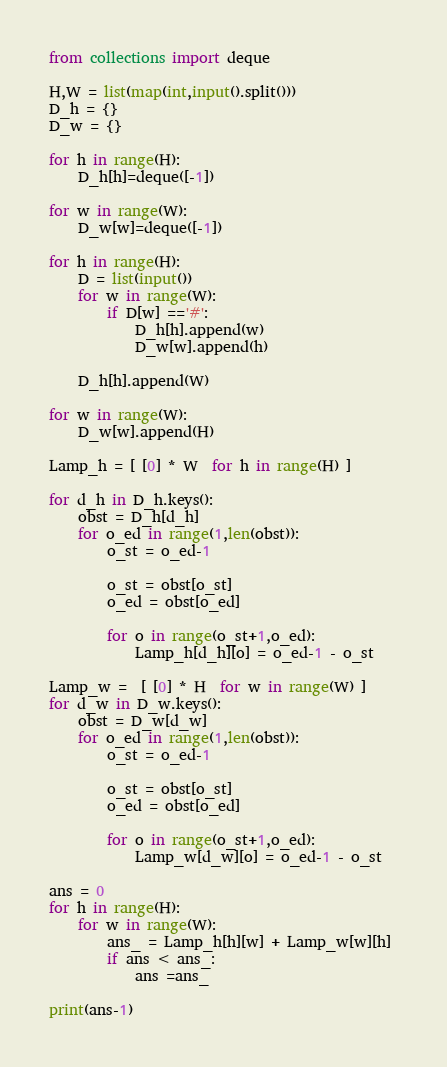Convert code to text. <code><loc_0><loc_0><loc_500><loc_500><_Python_>from collections import deque

H,W = list(map(int,input().split()))
D_h = {}
D_w = {}

for h in range(H):
    D_h[h]=deque([-1])
    
for w in range(W):
    D_w[w]=deque([-1])
    
for h in range(H):
    D = list(input())
    for w in range(W):
        if D[w] =='#':
            D_h[h].append(w)
            D_w[w].append(h)
            
    D_h[h].append(W)
    
for w in range(W):
    D_w[w].append(H)
    
Lamp_h = [ [0] * W  for h in range(H) ]

for d_h in D_h.keys():
    obst = D_h[d_h]
    for o_ed in range(1,len(obst)):
        o_st = o_ed-1
        
        o_st = obst[o_st]
        o_ed = obst[o_ed]
        
        for o in range(o_st+1,o_ed):
            Lamp_h[d_h][o] = o_ed-1 - o_st
    
Lamp_w =  [ [0] * H  for w in range(W) ]
for d_w in D_w.keys():
    obst = D_w[d_w]
    for o_ed in range(1,len(obst)):
        o_st = o_ed-1
        
        o_st = obst[o_st]
        o_ed = obst[o_ed]
        
        for o in range(o_st+1,o_ed):
            Lamp_w[d_w][o] = o_ed-1 - o_st
    
ans = 0
for h in range(H):
    for w in range(W):
        ans_ = Lamp_h[h][w] + Lamp_w[w][h] 
        if ans < ans_:
            ans =ans_
        
print(ans-1)</code> 